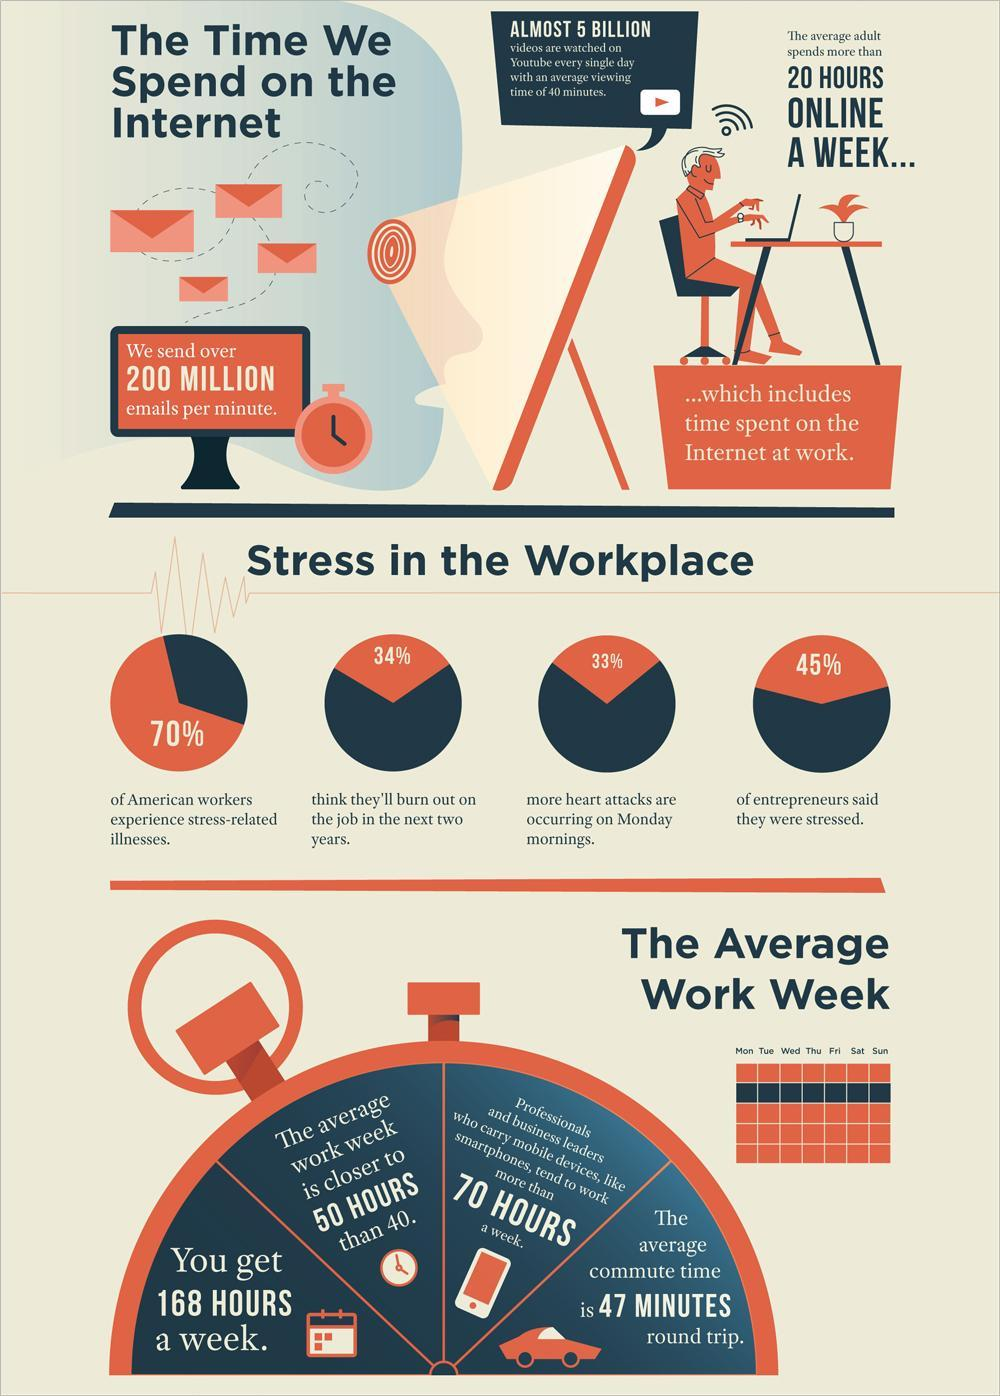What percentage of entrepreneurs said they were stressed?
Answer the question with a short phrase. 45% What percentage of American workers experience stress-related illnesses? 70% 